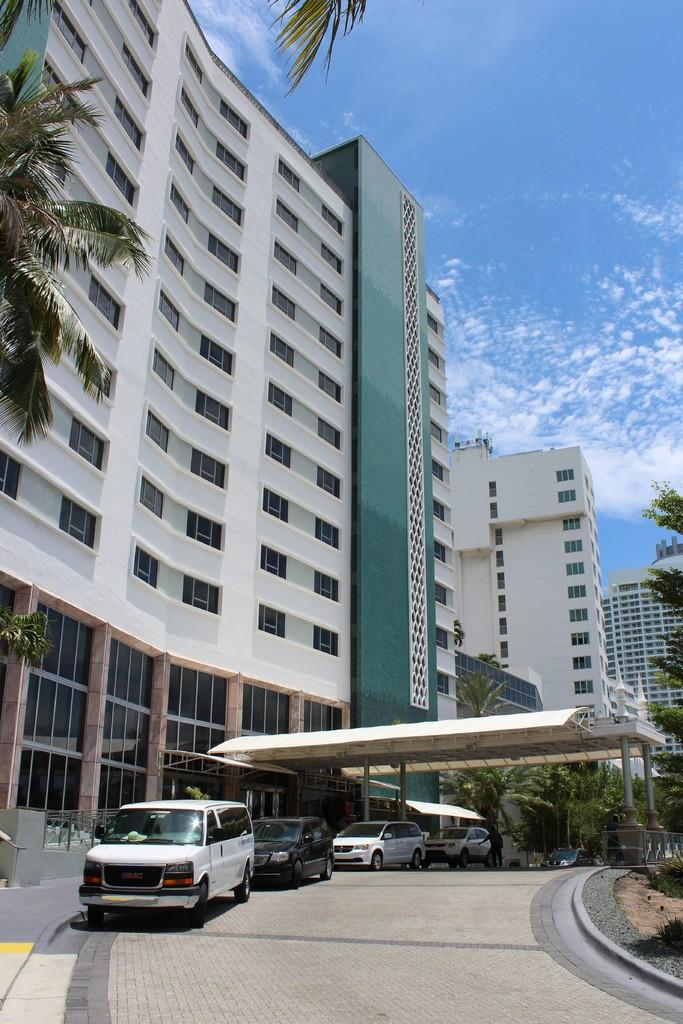What type of structure is present in the image? There is a building in the image. What else can be seen on the ground in the image? There are cars on a path in the image. What type of vegetation is visible in the image? There are trees visible in the image. What is visible in the background of the image? The sky is visible in the background of the image. What can be observed in the sky? There are clouds in the sky. What type of apparatus is being used by the trees in the image? There is no apparatus being used by the trees in the image; they are simply standing. What type of wool can be seen on the cars in the image? There is no wool present on the cars in the image. 